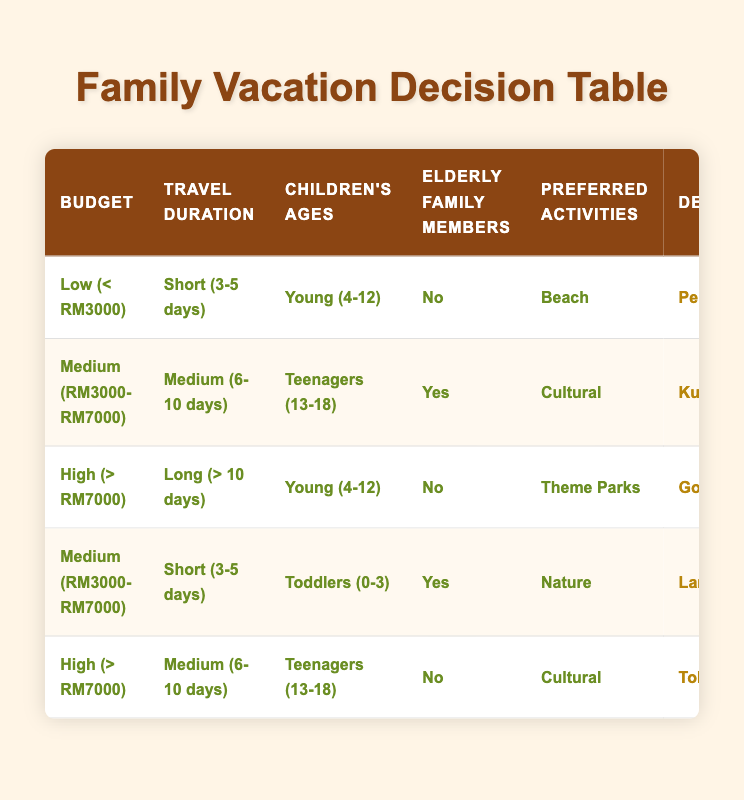What is the destination for a family on a low budget and short travel duration with young children? The table shows that for a low budget (less than RM3000), short travel duration (3-5 days), young children's ages (4-12), and no elderly family members, the destination is Penang.
Answer: Penang What meal plan is suggested for families traveling to Langkawi with toddlers and elderly members? According to the table, for families on a medium budget (RM3000-RM7000), traveling for a short duration (3-5 days), with toddlers and elderly members, the suggested meal plan is half-board.
Answer: Half-board Is a luxury resort recommended for a family with teenagers traveling to Tokyo? The table indicates that for families with teenagers (ages 13-18), in a high budget scenario (more than RM7000) traveling for a medium duration (6-10 days), a luxury resort is indeed recommended when visiting Tokyo.
Answer: Yes How many destinations are listed for families preferring beach activities? By reviewing the table, there is one destination (Penang) listed for families on a low budget, short duration, with young children, preferring beach activities.
Answer: One Which accommodation type is suggested for a family visiting the Gold Coast? The table specifies that for families with a high budget (more than RM7000), long travel duration (more than 10 days), young children's ages (4-12), and preferring theme parks, the suggested accommodation type is a vacation rental.
Answer: Vacation rental What is the average budget range of destinations listed in the table? The budget ranges across all destinations are low, medium, and high. Since there are three ranges, we cannot compute an average like a numerical value; however, we can summarize that the destinations span across these three budget categories equally.
Answer: N/A For families with teenagers planning a cultural trip and having elderly members, which destination is recommended? The table states that for a medium budget (RM3000-RM7000) and medium travel duration (6-10 days) with teenagers and elderly members, the recommended destination is Kuching.
Answer: Kuching Is it true that self-catering is the meal plan for families visiting Gold Coast? The table indicates that for families with a high budget (greater than RM7000) heading to Gold Coast, the meal plan is actually self-catering. Hence, the answer is true.
Answer: True Which destination offers a guided tour transportation option? According to the table, Langkawi is the destination listed for families on a medium budget, traveling for a short duration with toddlers and elderly members, and offers guided tour as a transportation option.
Answer: Langkawi 